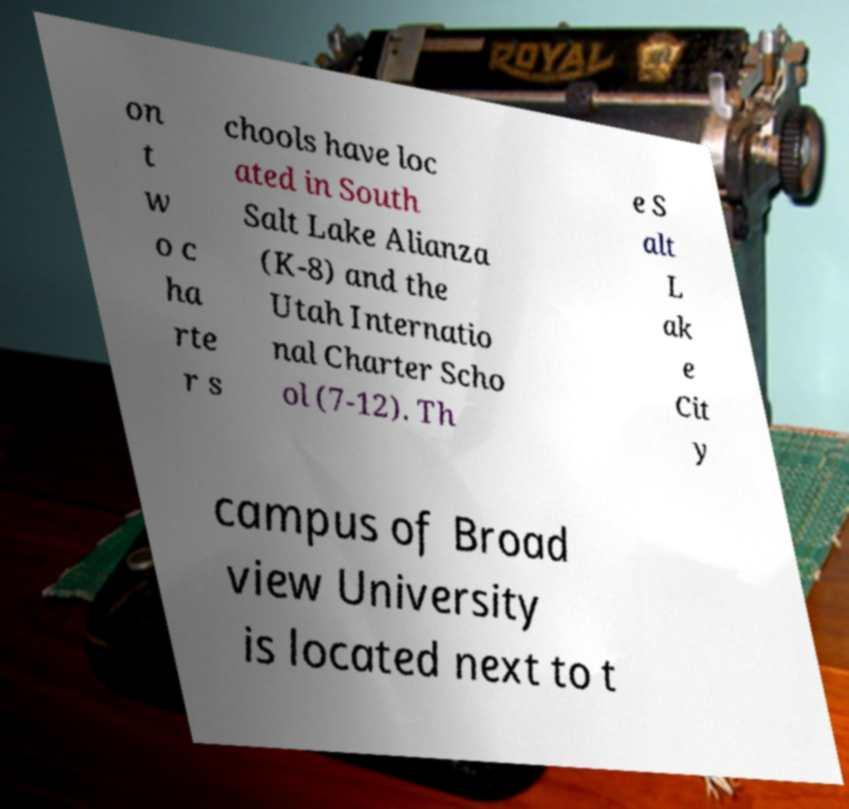I need the written content from this picture converted into text. Can you do that? on t w o c ha rte r s chools have loc ated in South Salt Lake Alianza (K-8) and the Utah Internatio nal Charter Scho ol (7-12). Th e S alt L ak e Cit y campus of Broad view University is located next to t 